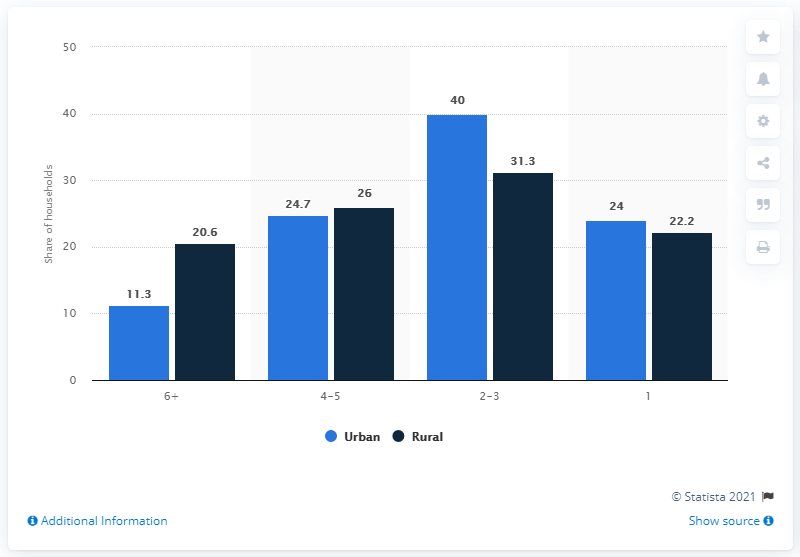Draw attention to some important aspects in this diagram. In rural areas, approximately 20.6% of households were comprised of six or more people, according to the data. 